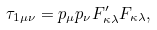<formula> <loc_0><loc_0><loc_500><loc_500>\tau _ { 1 \mu \nu } = p _ { \mu } p _ { \nu } F ^ { \prime } _ { \kappa \lambda } F _ { \kappa \lambda } ,</formula> 